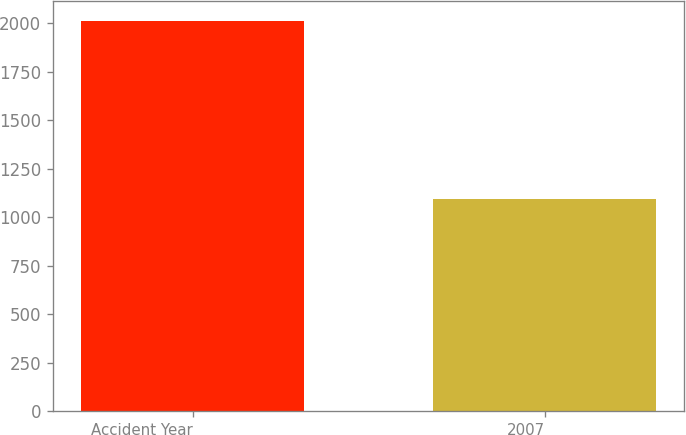<chart> <loc_0><loc_0><loc_500><loc_500><bar_chart><fcel>Accident Year<fcel>2007<nl><fcel>2014<fcel>1094<nl></chart> 